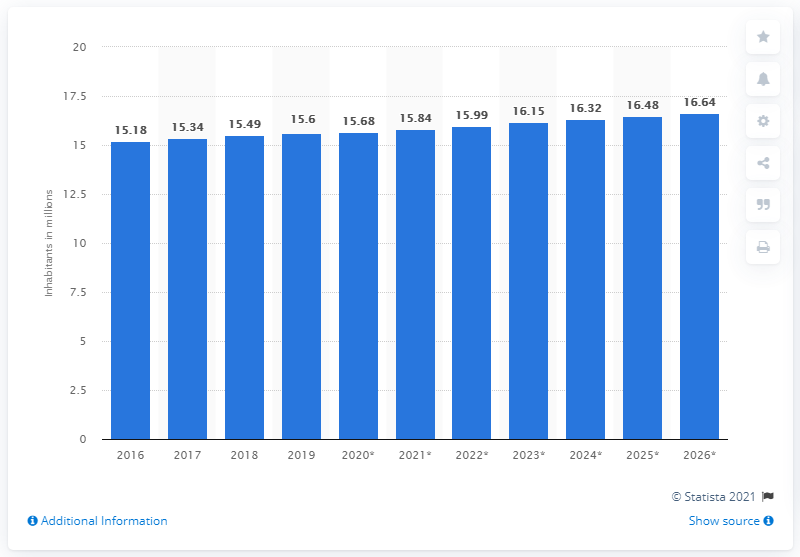Draw attention to some important aspects in this diagram. In 2020, the population of Cambodia was estimated to be 16.64 million. 